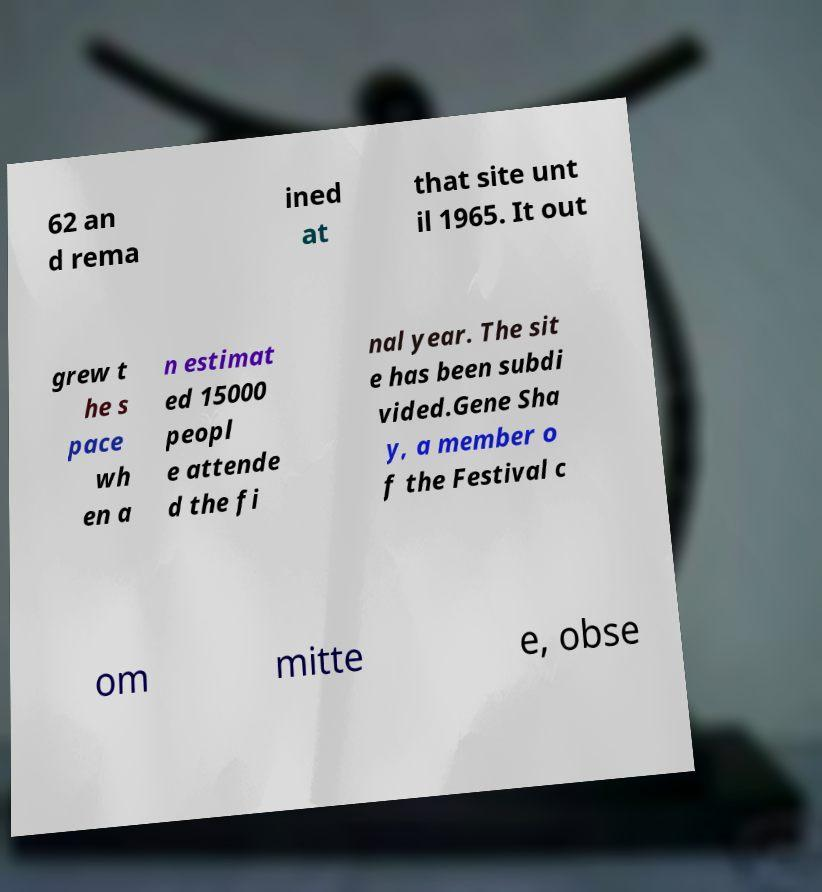What messages or text are displayed in this image? I need them in a readable, typed format. 62 an d rema ined at that site unt il 1965. It out grew t he s pace wh en a n estimat ed 15000 peopl e attende d the fi nal year. The sit e has been subdi vided.Gene Sha y, a member o f the Festival c om mitte e, obse 